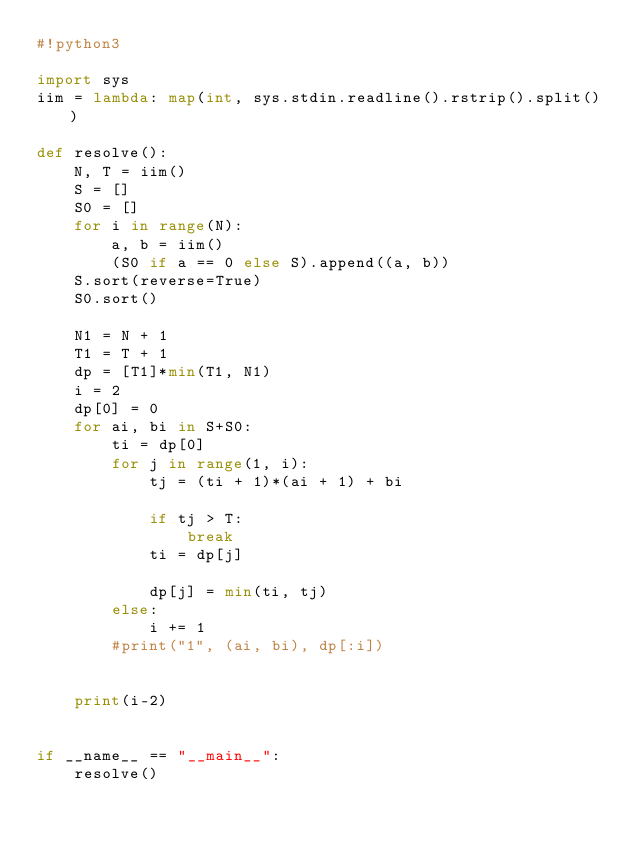Convert code to text. <code><loc_0><loc_0><loc_500><loc_500><_Python_>#!python3

import sys
iim = lambda: map(int, sys.stdin.readline().rstrip().split())

def resolve():
    N, T = iim()
    S = []
    S0 = []
    for i in range(N):
        a, b = iim()
        (S0 if a == 0 else S).append((a, b))
    S.sort(reverse=True)
    S0.sort()

    N1 = N + 1
    T1 = T + 1
    dp = [T1]*min(T1, N1)
    i = 2
    dp[0] = 0
    for ai, bi in S+S0:
        ti = dp[0]
        for j in range(1, i):
            tj = (ti + 1)*(ai + 1) + bi

            if tj > T:
                break
            ti = dp[j]

            dp[j] = min(ti, tj)
        else:
            i += 1
        #print("1", (ai, bi), dp[:i])


    print(i-2)


if __name__ == "__main__":
    resolve()
</code> 